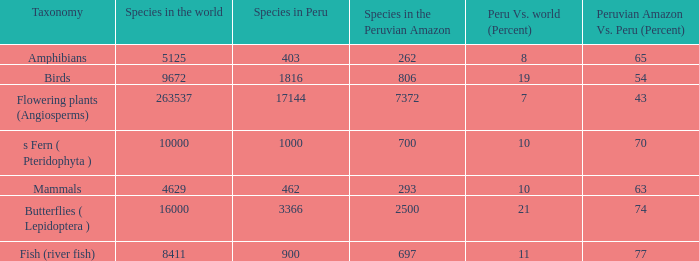Considering 8,411 species globally, how many of them can be found in the peruvian amazon? 1.0. Can you give me this table as a dict? {'header': ['Taxonomy', 'Species in the world', 'Species in Peru', 'Species in the Peruvian Amazon', 'Peru Vs. world (Percent)', 'Peruvian Amazon Vs. Peru (Percent)'], 'rows': [['Amphibians', '5125', '403', '262', '8', '65'], ['Birds', '9672', '1816', '806', '19', '54'], ['Flowering plants (Angiosperms)', '263537', '17144', '7372', '7', '43'], ['s Fern ( Pteridophyta )', '10000', '1000', '700', '10', '70'], ['Mammals', '4629', '462', '293', '10', '63'], ['Butterflies ( Lepidoptera )', '16000', '3366', '2500', '21', '74'], ['Fish (river fish)', '8411', '900', '697', '11', '77']]} 